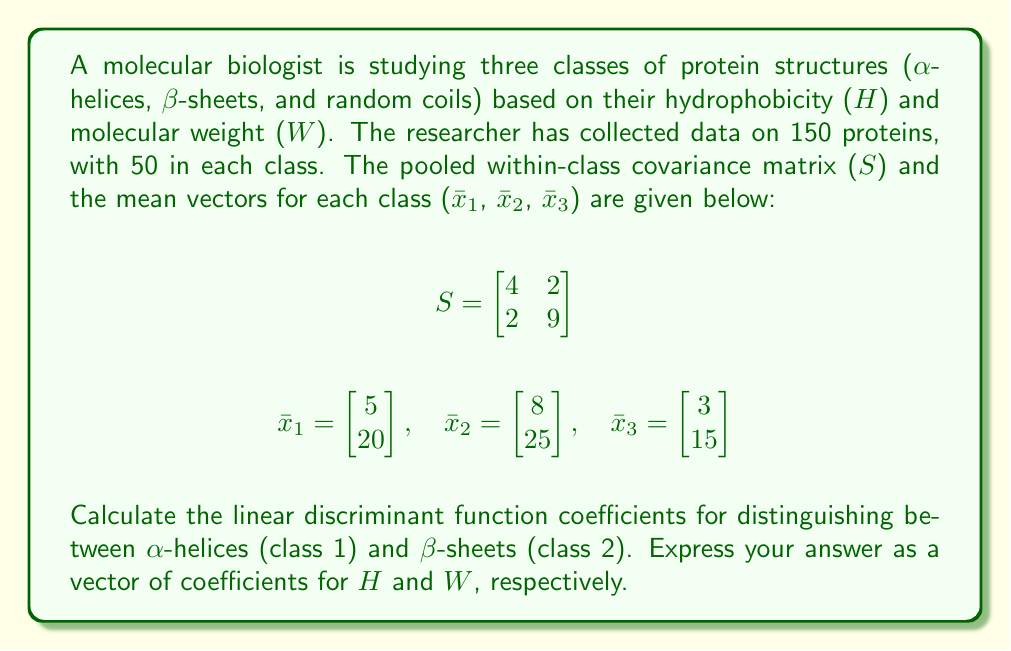Provide a solution to this math problem. To solve this problem, we'll use Fisher's linear discriminant analysis. The steps are as follows:

1) The linear discriminant function between two classes i and j is given by:

   $$a = S^{-1}(\bar{x}_i - \bar{x}_j)$$

   where $S^{-1}$ is the inverse of the pooled within-class covariance matrix.

2) First, we need to calculate $S^{-1}$. For a 2x2 matrix:

   $$S^{-1} = \frac{1}{ad-bc}\begin{bmatrix}
   d & -b \\
   -c & a
   \end{bmatrix}$$

   where $a=4$, $b=2$, $c=2$, and $d=9$.

3) Calculating $S^{-1}$:

   $$S^{-1} = \frac{1}{4(9)-2(2)}\begin{bmatrix}
   9 & -2 \\
   -2 & 4
   \end{bmatrix} = \frac{1}{32}\begin{bmatrix}
   9 & -2 \\
   -2 & 4
   \end{bmatrix}$$

4) Now we calculate $(\bar{x}_1 - \bar{x}_2)$:

   $$\bar{x}_1 - \bar{x}_2 = \begin{bmatrix}
   5 \\
   20
   \end{bmatrix} - \begin{bmatrix}
   8 \\
   25
   \end{bmatrix} = \begin{bmatrix}
   -3 \\
   -5
   \end{bmatrix}$$

5) Finally, we calculate $a = S^{-1}(\bar{x}_1 - \bar{x}_2)$:

   $$a = \frac{1}{32}\begin{bmatrix}
   9 & -2 \\
   -2 & 4
   \end{bmatrix}\begin{bmatrix}
   -3 \\
   -5
   \end{bmatrix}$$

   $$a = \frac{1}{32}\begin{bmatrix}
   9(-3) + (-2)(-5) \\
   (-2)(-3) + 4(-5)
   \end{bmatrix} = \frac{1}{32}\begin{bmatrix}
   -27 + 10 \\
   6 - 20
   \end{bmatrix} = \frac{1}{32}\begin{bmatrix}
   -17 \\
   -14
   \end{bmatrix}$$

   $$a = \begin{bmatrix}
   -0.53125 \\
   -0.4375
   \end{bmatrix}$$

This vector represents the coefficients for H and W in the linear discriminant function.
Answer: $a = \begin{bmatrix} -0.53125 \\ -0.4375 \end{bmatrix}$ 